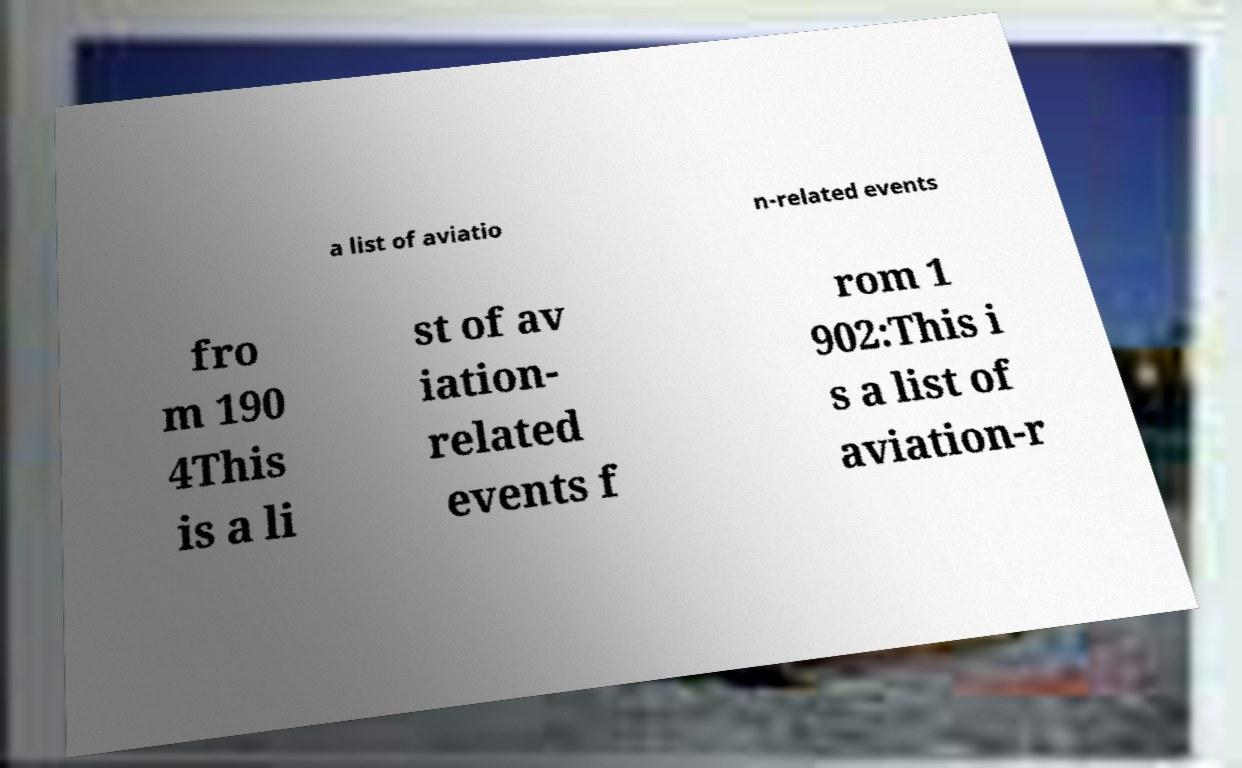There's text embedded in this image that I need extracted. Can you transcribe it verbatim? a list of aviatio n-related events fro m 190 4This is a li st of av iation- related events f rom 1 902:This i s a list of aviation-r 